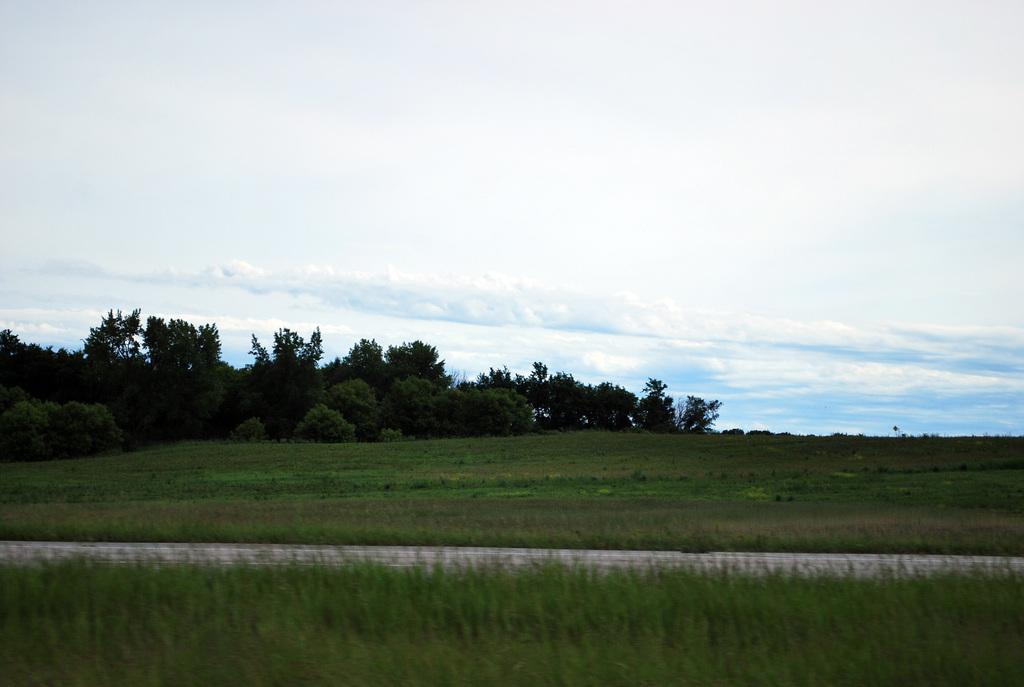Could you give a brief overview of what you see in this image? We can see grass. In the background we can see trees and sky with clouds. 